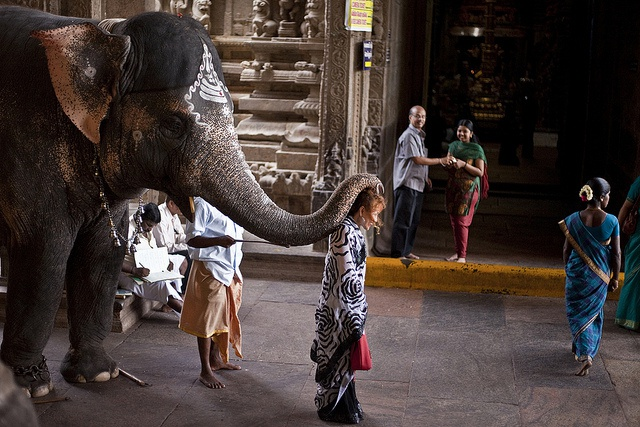Describe the objects in this image and their specific colors. I can see elephant in black, gray, maroon, and darkgray tones, people in black, gray, lavender, and darkgray tones, people in black, maroon, white, and gray tones, people in black, navy, blue, and gray tones, and people in black, white, gray, and maroon tones in this image. 